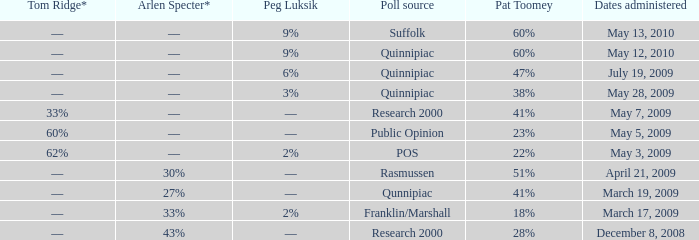Which Poll source has Pat Toomey of 23%? Public Opinion. 